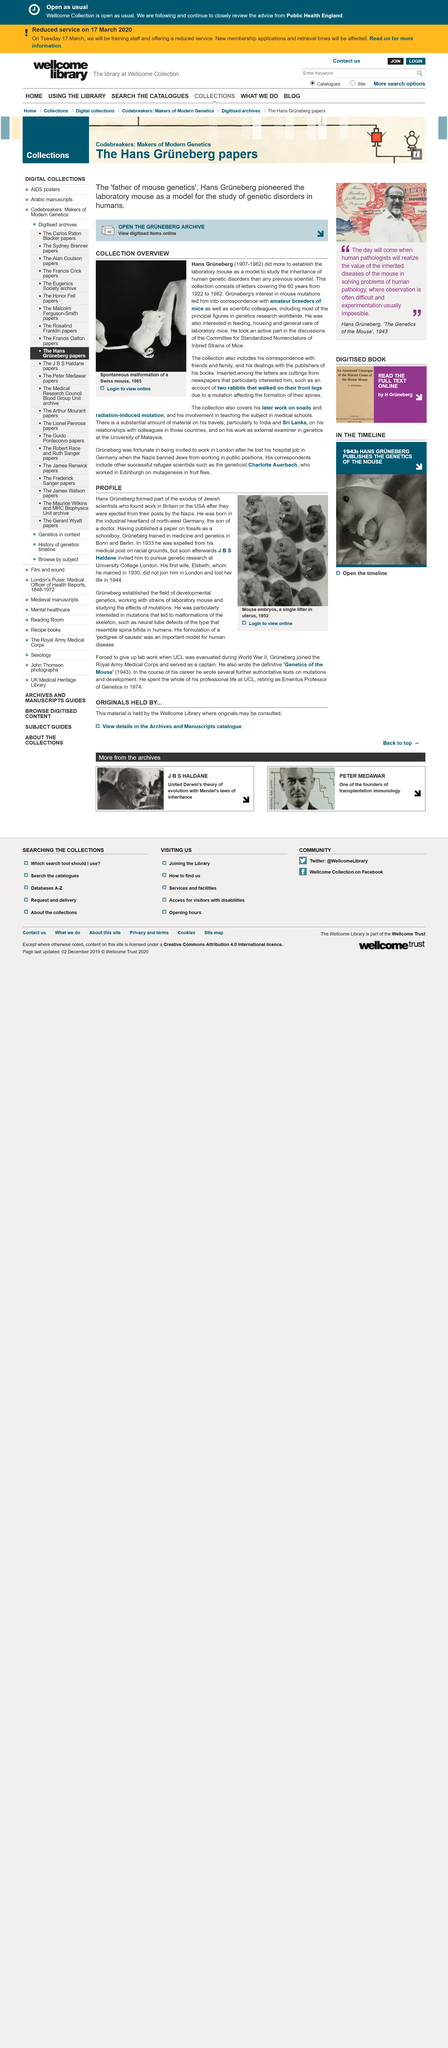Identify some key points in this picture. Hans Grüneberg was a researcher who specialized in the study of human genetic disorders and their inheritance. Hans Grüneberg and Elsbet were married in 1930. Hans Greenberg died in 1982. The exodus of Jewish scientists who were ejected from their posts by Nazis and found work in Britain or the USA includes Hans Grüneberg. The model used in the study was white. 